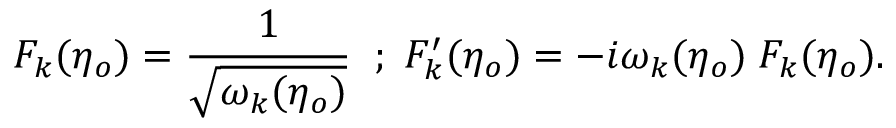<formula> <loc_0><loc_0><loc_500><loc_500>F _ { k } ( \eta _ { o } ) = \frac { 1 } { \sqrt { \omega _ { k } ( \eta _ { o } ) } } \, ; \, F _ { k } ^ { \prime } ( \eta _ { o } ) = - i \omega _ { k } ( \eta _ { o } ) \, F _ { k } ( \eta _ { o } ) .</formula> 